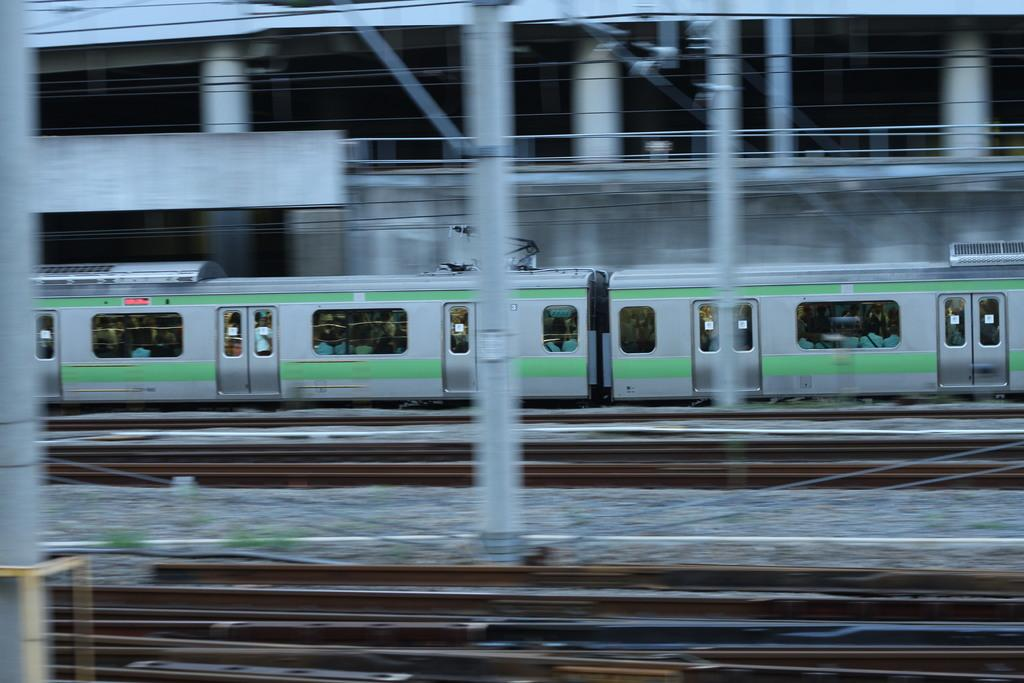What is the main subject of the image? The main subject of the image is groups of people in a train. Where is the train located? The train is on a railway track. What can be seen in the image besides the train? There are poles and wires in the image. What is visible in the background of the image? There is a building with pillars in the background. How many faucets can be seen in the image? There are no faucets present in the image. What type of ice is being served to the passengers in the train? There is no ice being served in the image; it only shows people in a train on a railway track. 